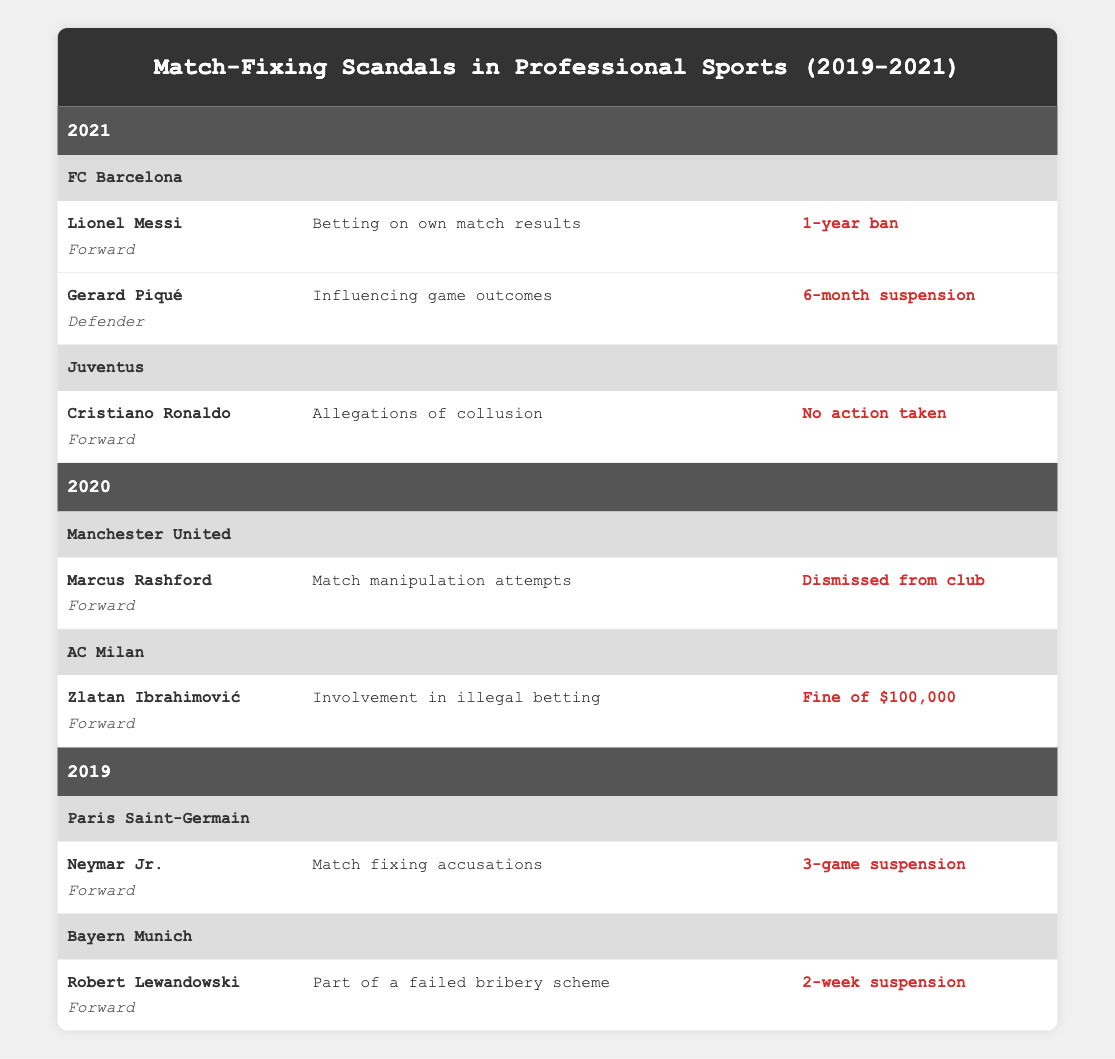What were the sanctions received by players from FC Barcelona in 2021? FC Barcelona had two players listed in 2021. Lionel Messi received a 1-year ban for betting on his own match results, while Gerard Piqué faced a 6-month suspension for influencing game outcomes.
Answer: 1-year ban and 6-month suspension Did any player from Juventus face a sanction in 2021? Cristiano Ronaldo from Juventus was involved in allegations of collusion, but no action was taken against him. Hence, he did not face any sanction.
Answer: No Who was sanctioned for match manipulation in 2020? In 2020, Marcus Rashford from Manchester United was sanctioned for match manipulation attempts and was dismissed from the club.
Answer: Marcus Rashford was dismissed from the club Which player had the lowest sanction in 2019? In 2019, Robert Lewandowski received a 2-week suspension for being part of a failed bribery scheme, which is the lowest sanction compared to Neymar Jr.'s 3-game suspension.
Answer: Robert Lewandowski What is the total number of players involved in match-fixing scandals across all teams in 2021? In 2021, there were three players involved: Lionel Messi and Gerard Piqué from FC Barcelona and Cristiano Ronaldo from Juventus. The total number is therefore 3.
Answer: 3 Which club had a player experiencing a fine in 2020, and what was the amount? AC Milan had Zlatan Ibrahimović, who was fined $100,000 for involvement in illegal betting in 2020.
Answer: AC Milan, $100,000 Was there any player from Paris Saint-Germain suspended in 2019, and if so, why? Yes, Neymar Jr. was suspended for 3 games due to match-fixing accusations in 2019.
Answer: Yes, for match-fixing accusations How many players were involved in match-fixing scandals overall from 2019 to 2021? From 2019 to 2021, there were a total of 7 players: 1 in 2019, 2 in 2021, and 2 in 2020. The total is calculated as 1 + 2 + 2 = 5.
Answer: 5 